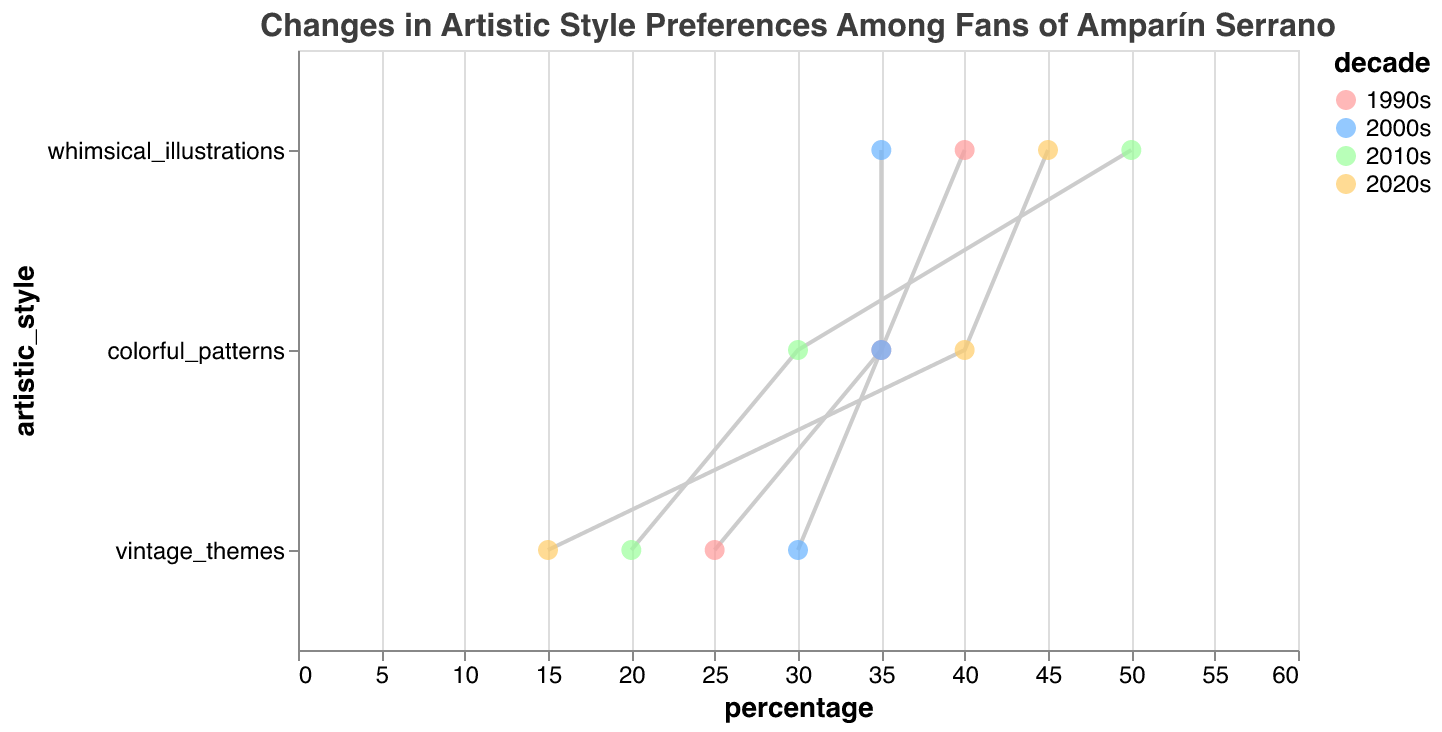What's the title of the plot? The title of the plot is displayed at the top and summarizes what the plot is about. In this case, it's "Changes in Artistic Style Preferences Among Fans of Amparín Serrano."
Answer: Changes in Artistic Style Preferences Among Fans of Amparín Serrano Which decade shows the highest preference for whimsical illustrations? To answer this, look for the highest percentage point on the whimsical illustrations line. In this case, the 2010s decade shows a 50% preference.
Answer: 2010s What was the percentage preference for vintage themes in the 1990s? Locate the vintage themes line and find the data point corresponding to the 1990s. The percentage is 25%.
Answer: 25% In which decade did colorful patterns have the lowest preference? Look at the colorful patterns line and find the lowest percentage point. The lowest preference of 30% occurs in the 2010s.
Answer: 2010s How much did the preference for vintage themes decline from the 1990s to the 2020s? Subtract the 2020s percentage for vintage themes from the 1990s percentage. 25% - 15% = 10%
Answer: 10% What is the average preference for whimsical illustrations over the decades shown? Sum the percentages for whimsical illustrations across all decades (40+35+50+45) and divide by the number of decades (4). (40 + 35 + 50 + 45) / 4 = 42.5%
Answer: 42.5% Which artistic style showed the most stable (least variable) preferences across the decades? Compare the range (difference between highest and lowest percentages) for each artistic style. Colorful patterns have the percentages 35%, 35%, 30%, 40%, thus a range of 10%.
Answer: colorful patterns Do vintage themes show an increasing or decreasing trend over the decades? By observing the trend line of vintage themes, we see percentages are 25%, 30%, 20%, 15%, showing a general decreasing trend.
Answer: decreasing How did the preference for colorful patterns change from the 2010s to the 2020s? Subtract the 2010s percentage from the 2020s percentage for colorful patterns. 40% - 30% = 10% increase.
Answer: increased by 10% Which artistic style had the highest percentage in the 2020s? Compare the 2020s percentages for whimsical illustrations, vintage themes, and colorful patterns. The highest percentage is whimsical illustrations at 45%.
Answer: whimsical illustrations 